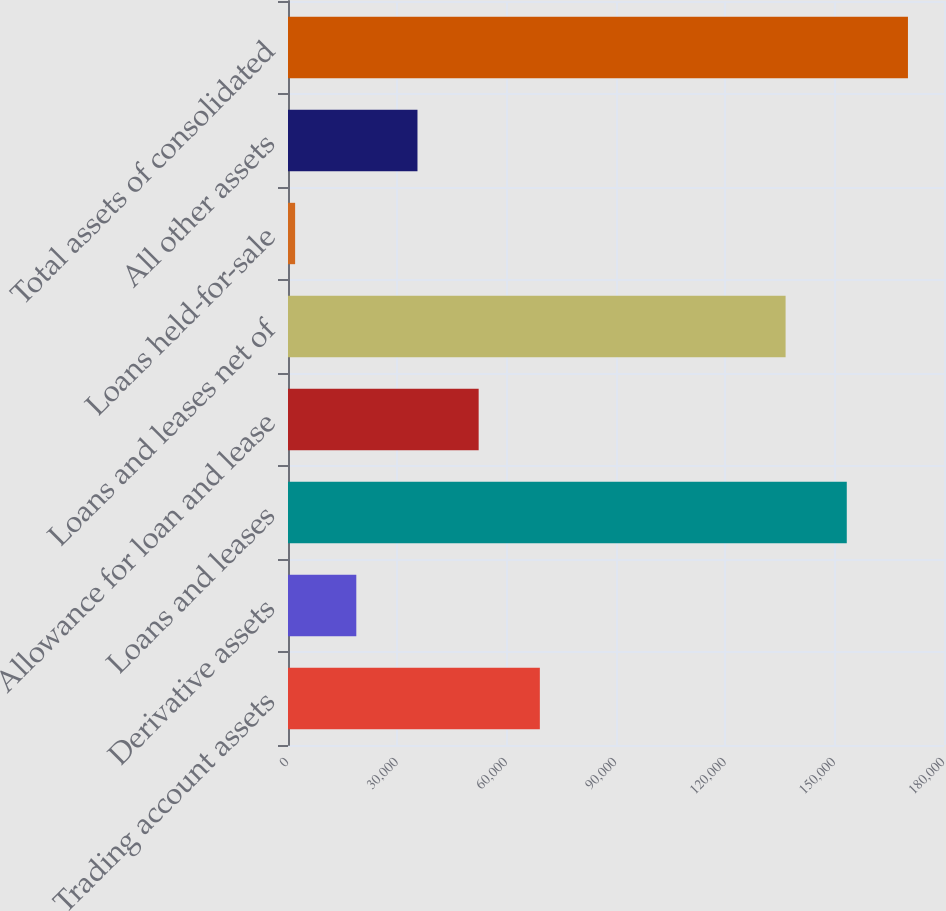<chart> <loc_0><loc_0><loc_500><loc_500><bar_chart><fcel>Trading account assets<fcel>Derivative assets<fcel>Loans and leases<fcel>Allowance for loan and lease<fcel>Loans and leases net of<fcel>Loans held-for-sale<fcel>All other assets<fcel>Total assets of consolidated<nl><fcel>69103<fcel>18740.5<fcel>153322<fcel>52315.5<fcel>136534<fcel>1953<fcel>35528<fcel>170109<nl></chart> 